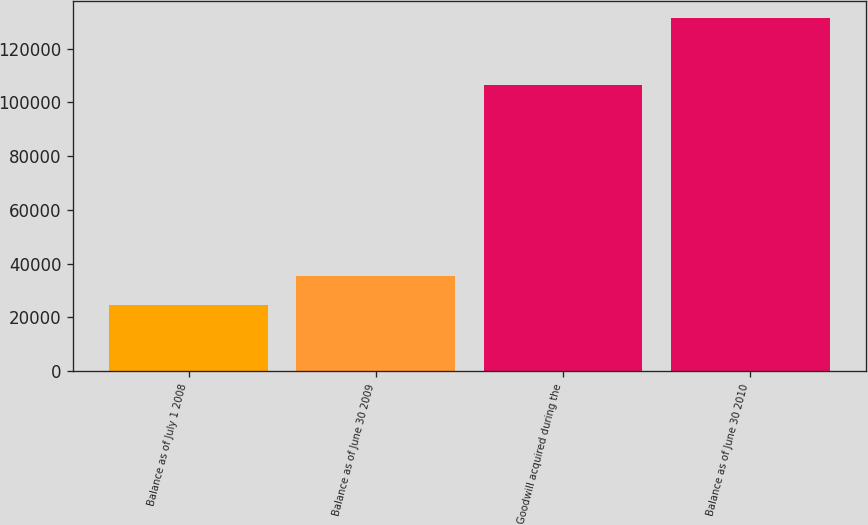<chart> <loc_0><loc_0><loc_500><loc_500><bar_chart><fcel>Balance as of July 1 2008<fcel>Balance as of June 30 2009<fcel>Goodwill acquired during the<fcel>Balance as of June 30 2010<nl><fcel>24798<fcel>35436.7<fcel>106387<fcel>131185<nl></chart> 